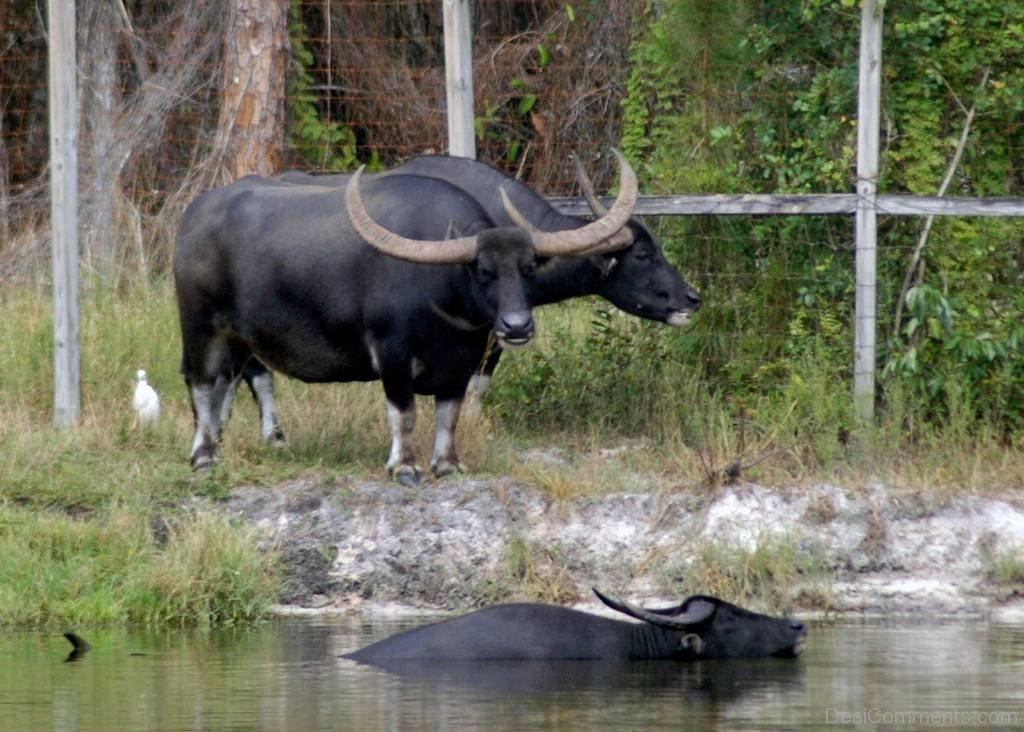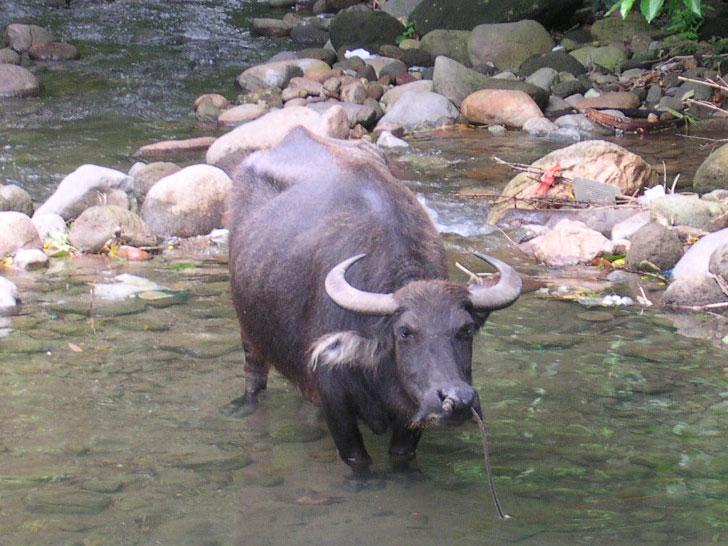The first image is the image on the left, the second image is the image on the right. For the images displayed, is the sentence "There is a total of 1 buffalo in water up to their head." factually correct? Answer yes or no. Yes. The first image is the image on the left, the second image is the image on the right. Evaluate the accuracy of this statement regarding the images: "a water buffalo is up to it's neck in water". Is it true? Answer yes or no. Yes. 